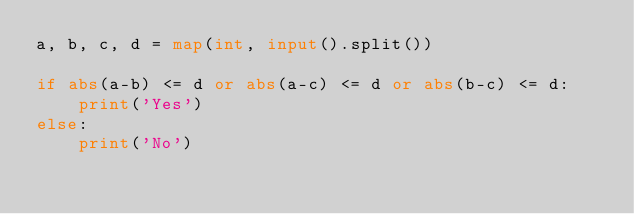<code> <loc_0><loc_0><loc_500><loc_500><_Python_>a, b, c, d = map(int, input().split())

if abs(a-b) <= d or abs(a-c) <= d or abs(b-c) <= d:
    print('Yes')
else:
    print('No')
</code> 